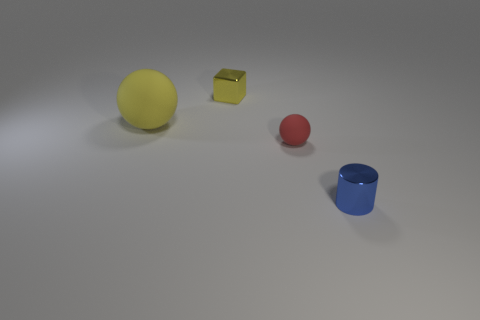Add 4 cyan matte cylinders. How many objects exist? 8 Subtract all blocks. How many objects are left? 3 Add 4 small blue things. How many small blue things are left? 5 Add 2 gray things. How many gray things exist? 2 Subtract 0 gray blocks. How many objects are left? 4 Subtract all large blue blocks. Subtract all yellow matte things. How many objects are left? 3 